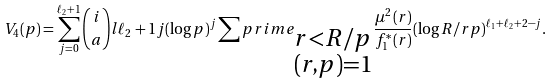Convert formula to latex. <formula><loc_0><loc_0><loc_500><loc_500>V _ { 4 } ( p ) = \sum _ { j = 0 } ^ { \ell _ { 2 } + 1 } \binom { i } { a } l { \ell _ { 2 } + 1 } { j } ( \log p ) ^ { j } \sum p r i m e _ { \substack { r < R / p \\ ( r , p ) = 1 } } \frac { \mu ^ { 2 } ( r ) } { f _ { 1 } ^ { * } ( r ) } ( \log R / r p ) ^ { \ell _ { 1 } + \ell _ { 2 } + 2 - j } .</formula> 